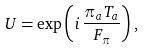<formula> <loc_0><loc_0><loc_500><loc_500>U = \exp \left ( i \, \frac { \pi _ { a } T _ { a } } { F _ { \pi } } \right ) ,</formula> 